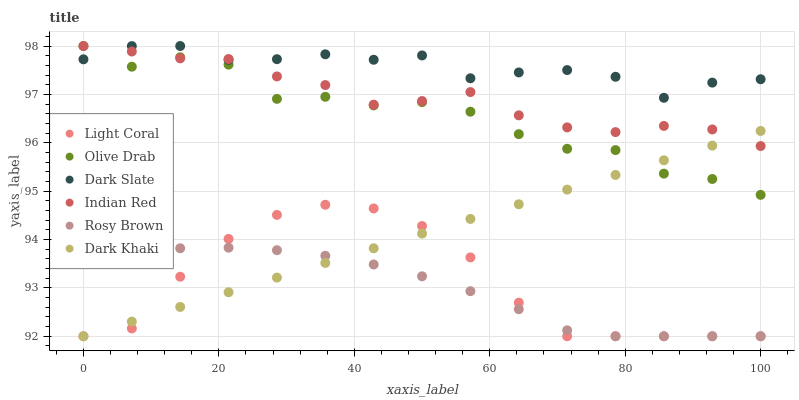Does Rosy Brown have the minimum area under the curve?
Answer yes or no. Yes. Does Dark Slate have the maximum area under the curve?
Answer yes or no. Yes. Does Light Coral have the minimum area under the curve?
Answer yes or no. No. Does Light Coral have the maximum area under the curve?
Answer yes or no. No. Is Dark Khaki the smoothest?
Answer yes or no. Yes. Is Olive Drab the roughest?
Answer yes or no. Yes. Is Rosy Brown the smoothest?
Answer yes or no. No. Is Rosy Brown the roughest?
Answer yes or no. No. Does Dark Khaki have the lowest value?
Answer yes or no. Yes. Does Dark Slate have the lowest value?
Answer yes or no. No. Does Olive Drab have the highest value?
Answer yes or no. Yes. Does Light Coral have the highest value?
Answer yes or no. No. Is Rosy Brown less than Indian Red?
Answer yes or no. Yes. Is Dark Slate greater than Dark Khaki?
Answer yes or no. Yes. Does Dark Khaki intersect Light Coral?
Answer yes or no. Yes. Is Dark Khaki less than Light Coral?
Answer yes or no. No. Is Dark Khaki greater than Light Coral?
Answer yes or no. No. Does Rosy Brown intersect Indian Red?
Answer yes or no. No. 